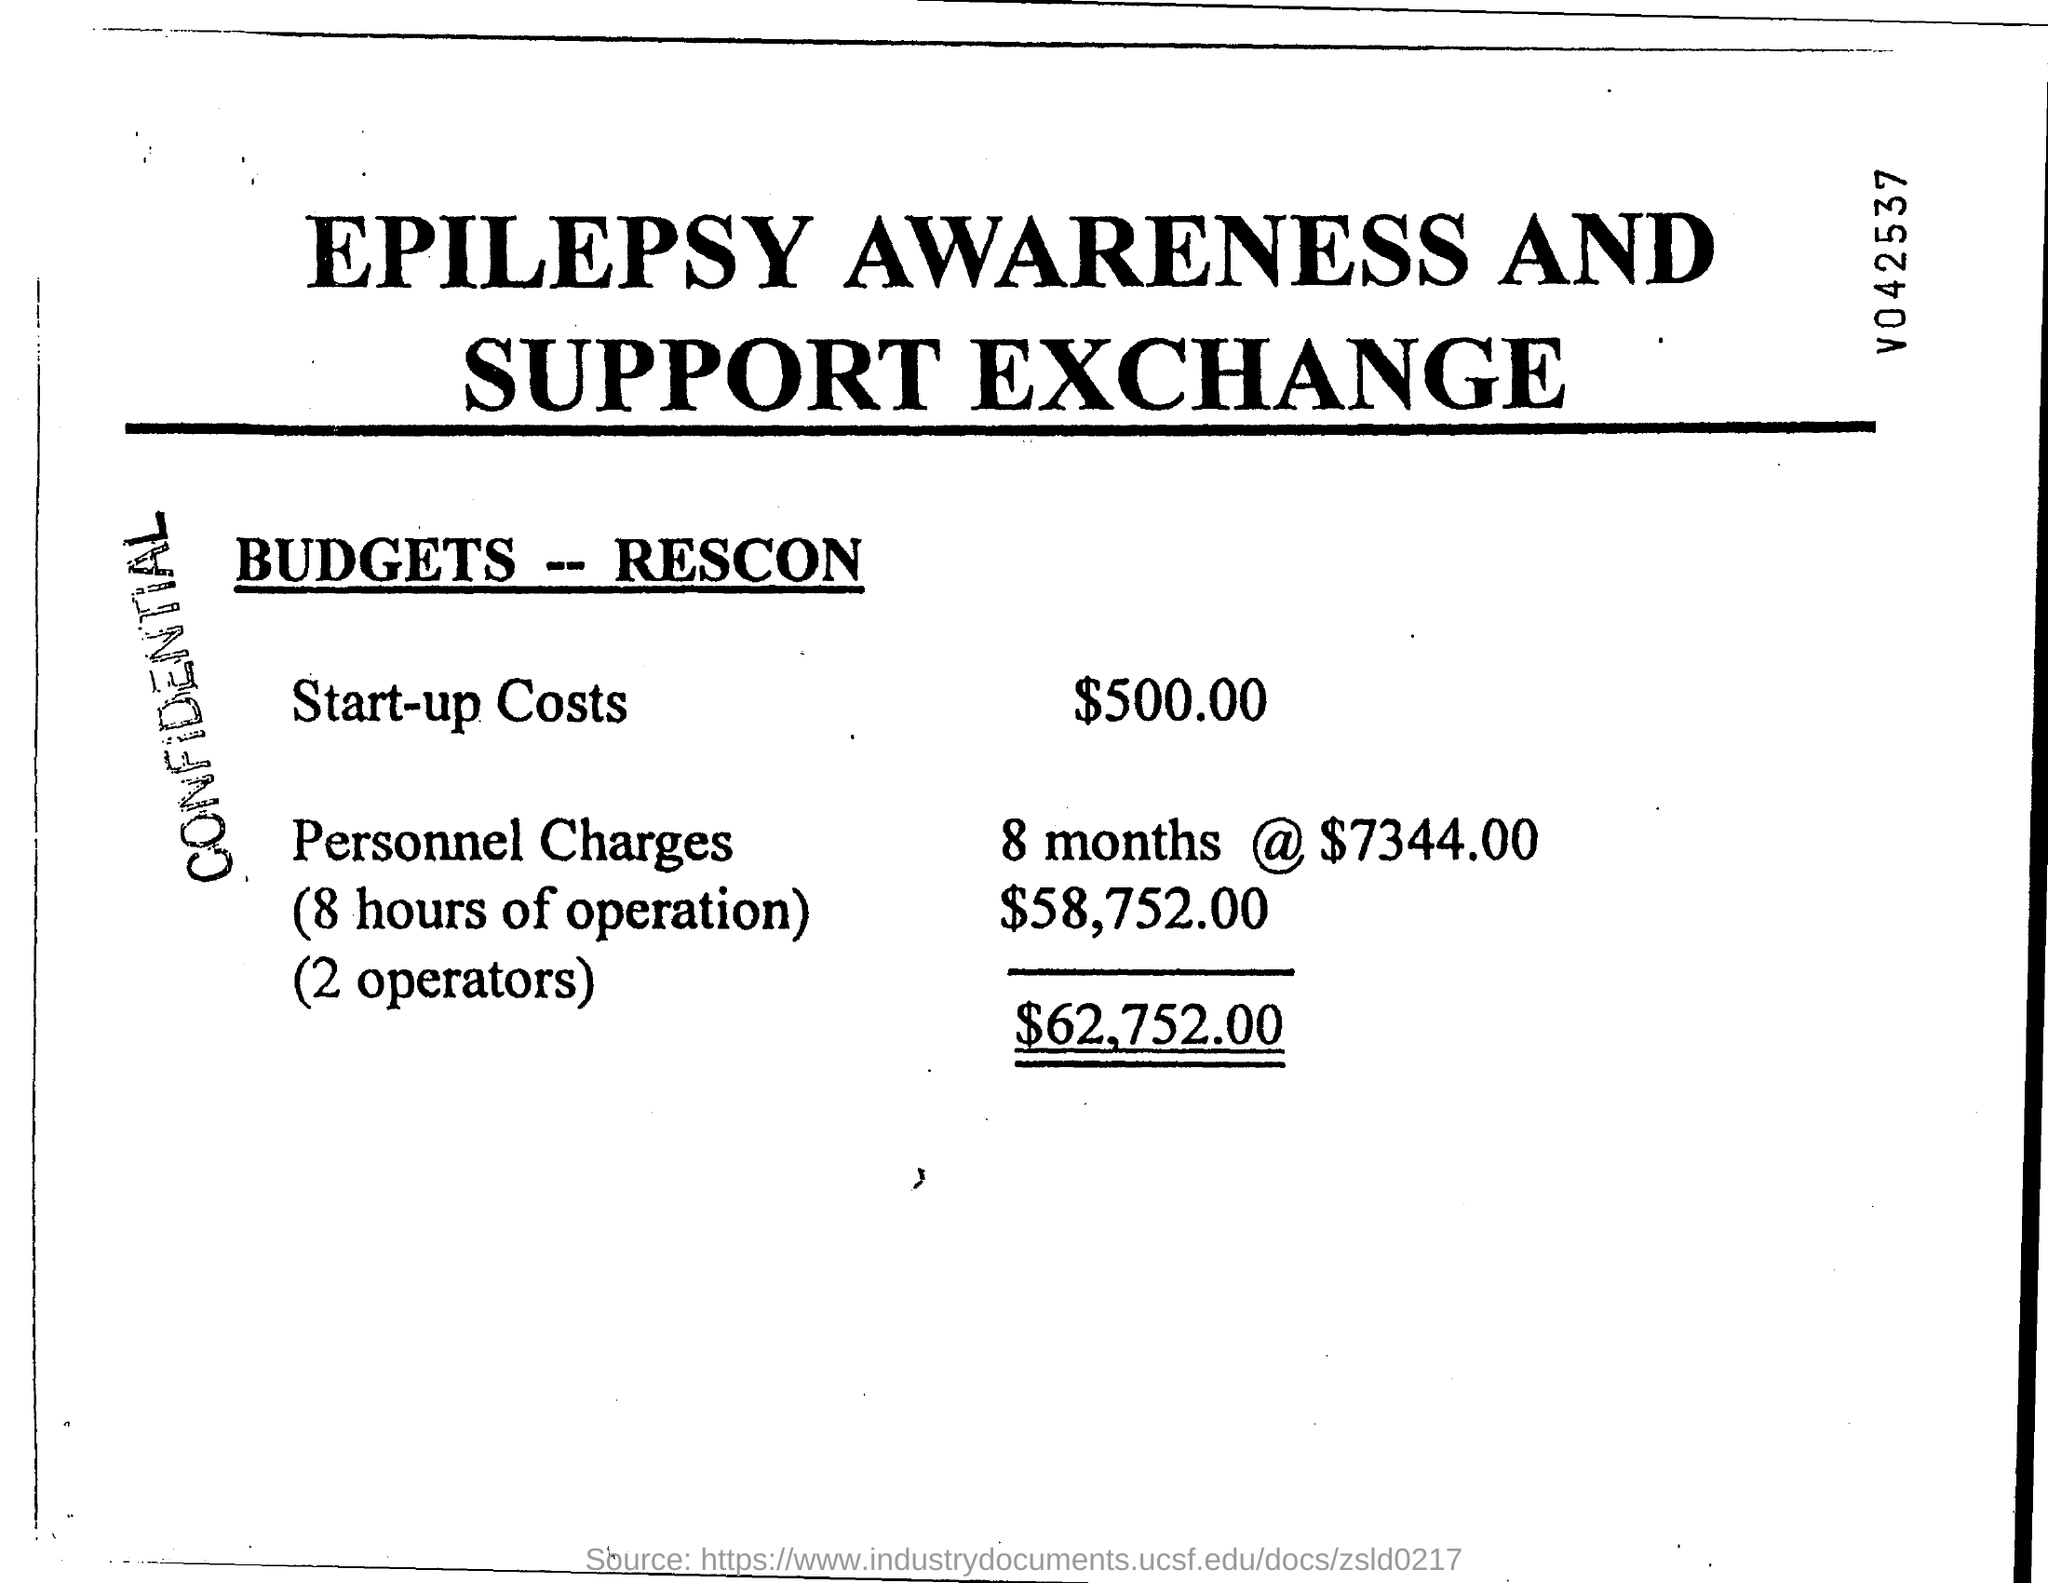What is start-up costs ?
Offer a very short reply. $500.00. What is the total budgets-rescon?
Provide a short and direct response. $62,752.00. 